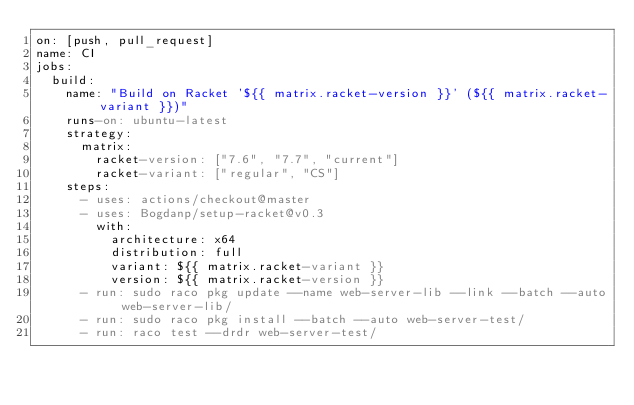<code> <loc_0><loc_0><loc_500><loc_500><_YAML_>on: [push, pull_request]
name: CI
jobs:
  build:
    name: "Build on Racket '${{ matrix.racket-version }}' (${{ matrix.racket-variant }})"
    runs-on: ubuntu-latest
    strategy:
      matrix:
        racket-version: ["7.6", "7.7", "current"]
        racket-variant: ["regular", "CS"]
    steps:
      - uses: actions/checkout@master
      - uses: Bogdanp/setup-racket@v0.3
        with:
          architecture: x64
          distribution: full
          variant: ${{ matrix.racket-variant }}
          version: ${{ matrix.racket-version }}
      - run: sudo raco pkg update --name web-server-lib --link --batch --auto web-server-lib/
      - run: sudo raco pkg install --batch --auto web-server-test/
      - run: raco test --drdr web-server-test/
</code> 